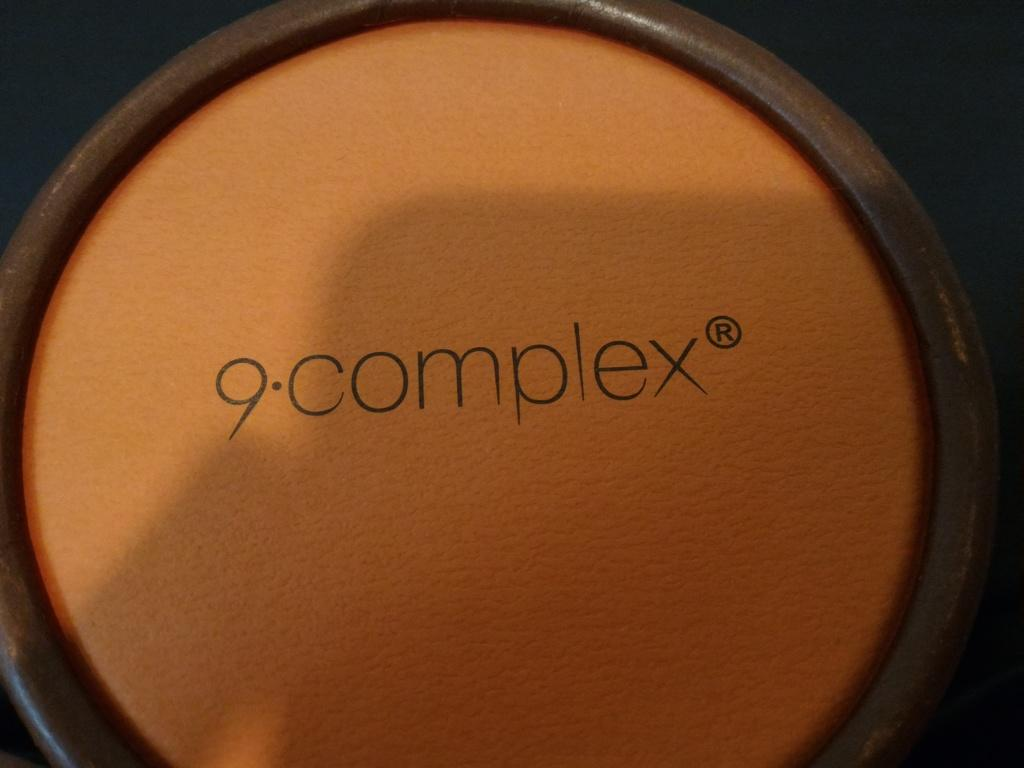Provide a one-sentence caption for the provided image. A circular object that has 9 complex written on it. 